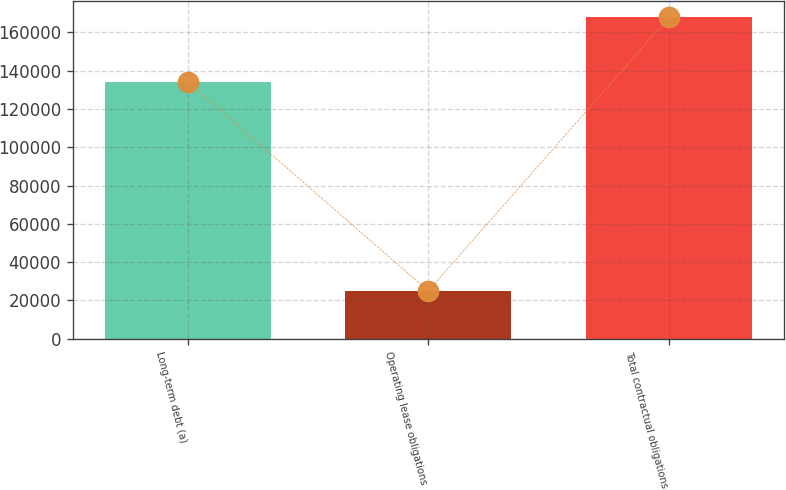Convert chart. <chart><loc_0><loc_0><loc_500><loc_500><bar_chart><fcel>Long-term debt (a)<fcel>Operating lease obligations<fcel>Total contractual obligations<nl><fcel>134250<fcel>24921<fcel>167849<nl></chart> 